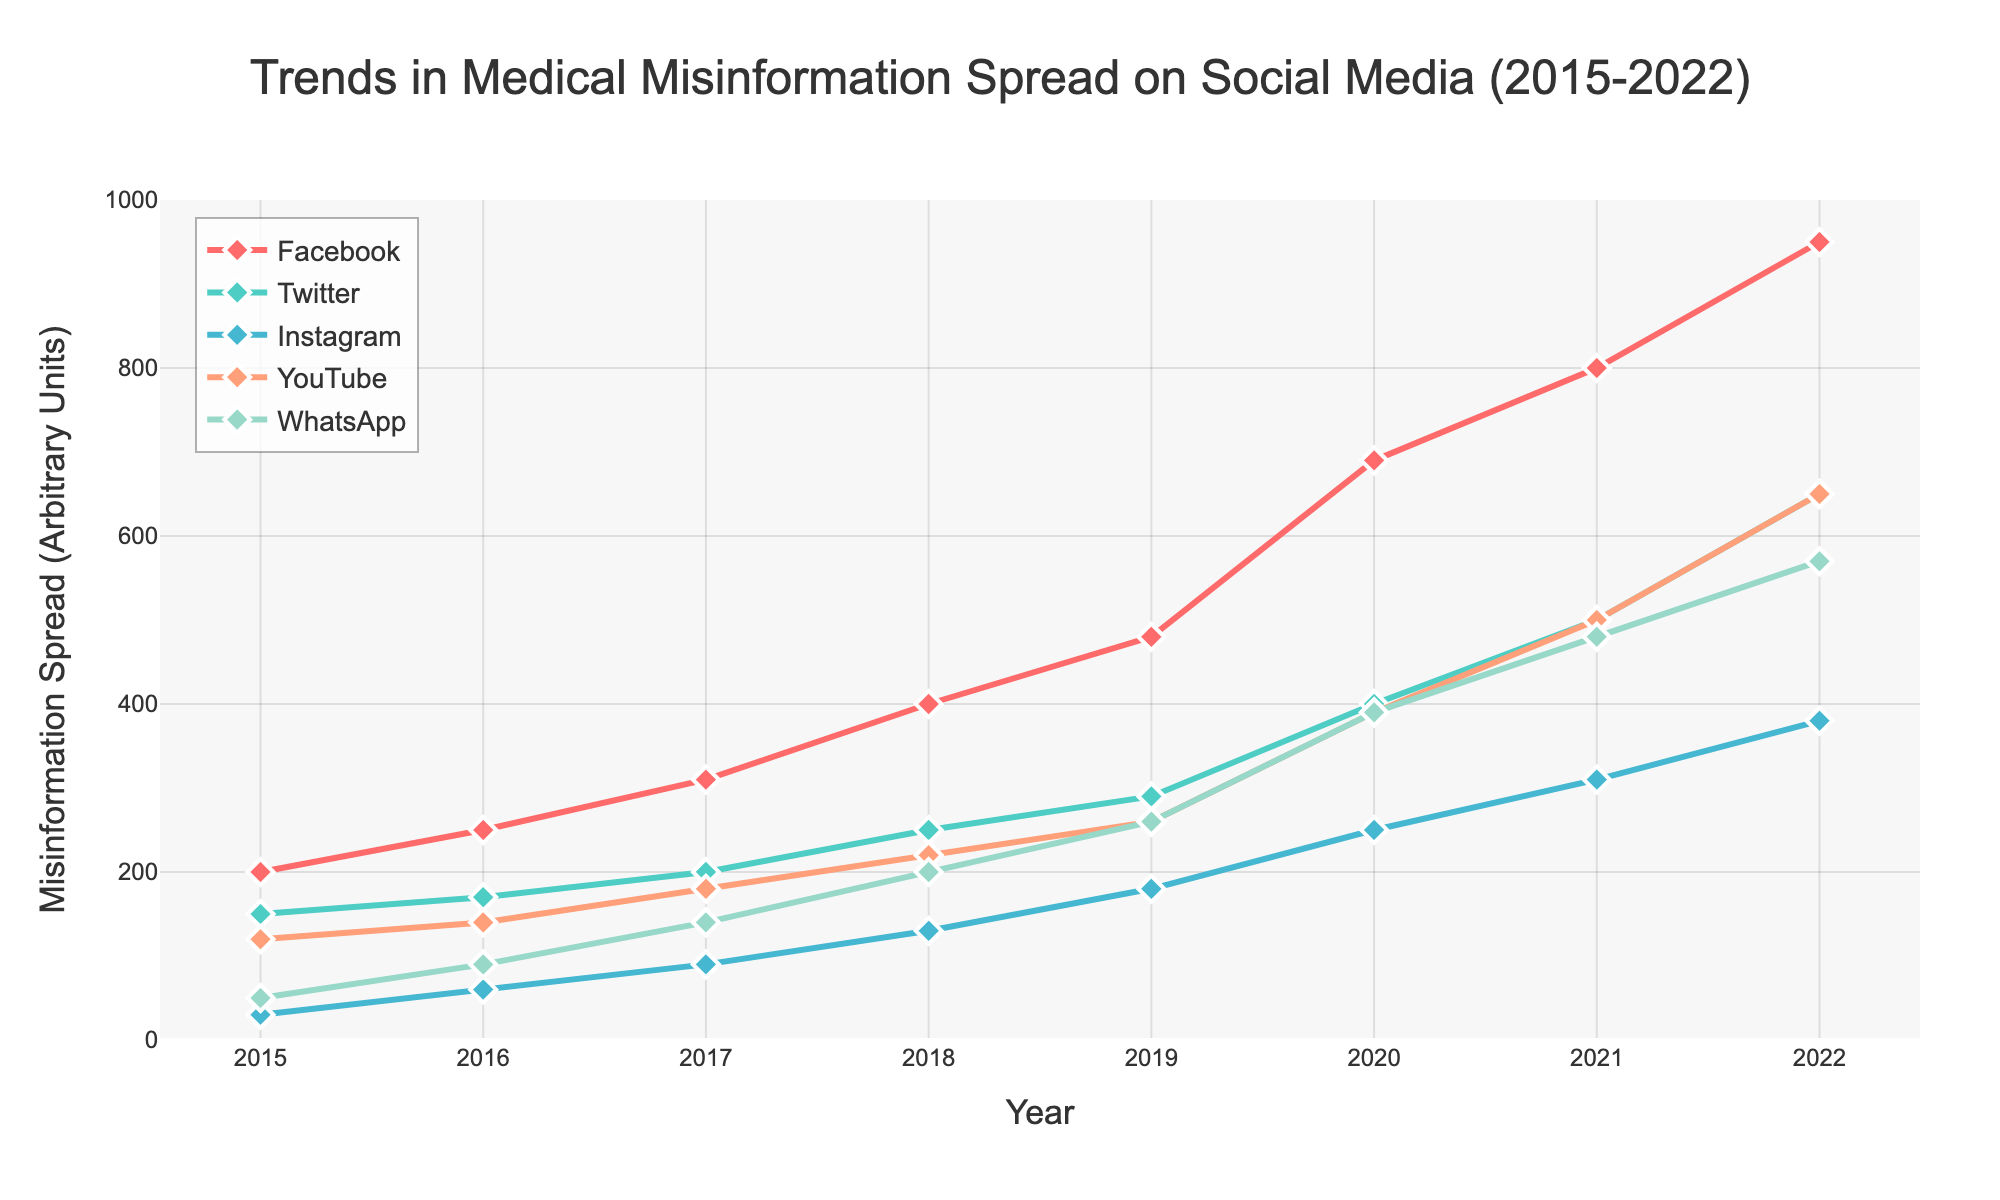What is the title of the figure? The title of the figure is displayed at the top and is a succinct summary of the data being visualized. You can find it centered just above the plot area.
Answer: Trends in Medical Misinformation Spread on Social Media (2015-2022) What is the range of years shown in the figure? The x-axis shows the range of years. It starts from the leftmost point and ends at the rightmost point.
Answer: 2015-2022 Which platform had the highest misinformation spread in 2022? To determine this, look at the plotted lines and their corresponding values on the y-axis for the year 2022. Compare the values for all platforms.
Answer: Facebook How did the spread of misinformation on Twitter change from 2015 to 2022? Locate the markers for Twitter (second line from the top) at 2015 and 2022, then note the values on the y-axis to see the trend.
Answer: It increased Which platform saw the most significant increase in misinformation spread from 2015 to 2022? Check the starting and ending points of each line in the plot. Calculate the difference in y-values for each platform to find which had the highest increase.
Answer: Facebook What is the approximate spread of misinformation on WhatsApp in 2019? Find the marker for WhatsApp (fifth line from the top) at 2019, then follow it horizontally to the y-axis to read the value.
Answer: 260 Between which consecutive years did Instagram see the largest increase in misinformation spread? For Instagram (third line from the top), identify the years where the slope of the line is steepest by comparing the differences in y-values year by year.
Answer: 2016 to 2017 By how much did YouTube misinformation spread grow from 2018 to 2020? Locate the markers for YouTube (fourth line from the top) at 2018 and 2020, note their y-values, and subtract the 2018 value from the 2020 value.
Answer: 170 Which platforms experienced a significant increase in misinformation spread in 2020? Look at the slopes of all lines around 2020 and identify which lines have a steep upward trajectory.
Answer: Facebook, Twitter, YouTube, WhatsApp What can be inferred about the general trend in misinformation spread across all platforms from 2015 to 2022? Observing the overall direction and growth patterns of all lines helps infer whether the misinformation spread has increased, decreased, or remained stable.
Answer: It increased significantly across all platforms 